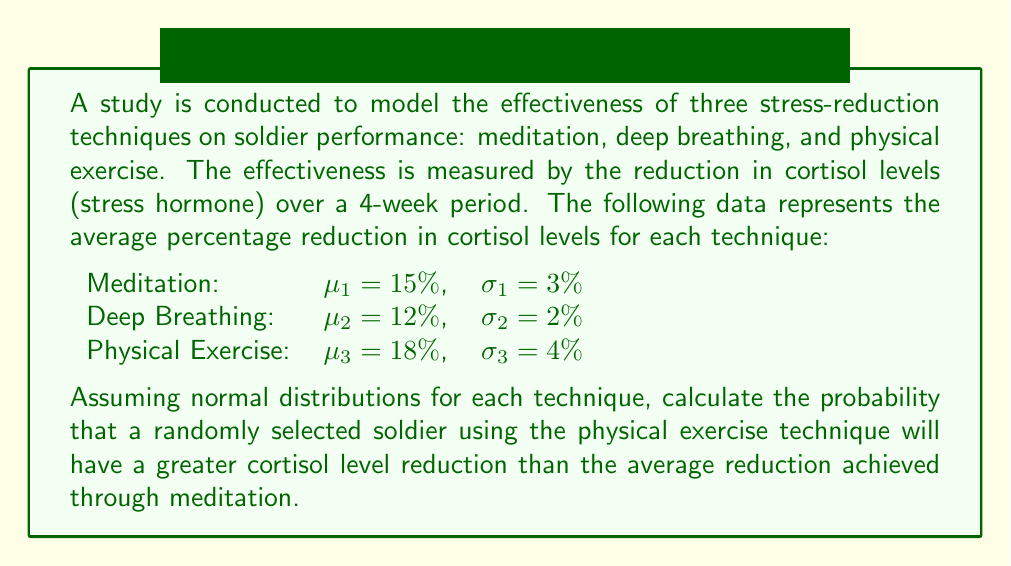Give your solution to this math problem. To solve this problem, we need to follow these steps:

1. Identify the distributions:
   - Physical Exercise: $X \sim N(\mu_3 = 18\%, \sigma_3 = 4\%)$
   - Meditation (average): $\mu_1 = 15\%$

2. We need to find $P(X > 15\%)$

3. Standardize the normal distribution:
   $$Z = \frac{X - \mu}{\sigma} = \frac{15\% - 18\%}{4\%} = -0.75$$

4. Use the standard normal distribution table or a calculator to find the probability:
   $$P(X > 15\%) = P(Z > -0.75) = 1 - P(Z < -0.75)$$

5. From the standard normal distribution table:
   $$P(Z < -0.75) \approx 0.2266$$

6. Therefore:
   $$P(X > 15\%) = 1 - 0.2266 = 0.7734$$

This means there is approximately a 77.34% chance that a randomly selected soldier using the physical exercise technique will have a greater cortisol level reduction than the average reduction achieved through meditation.
Answer: 0.7734 or 77.34% 